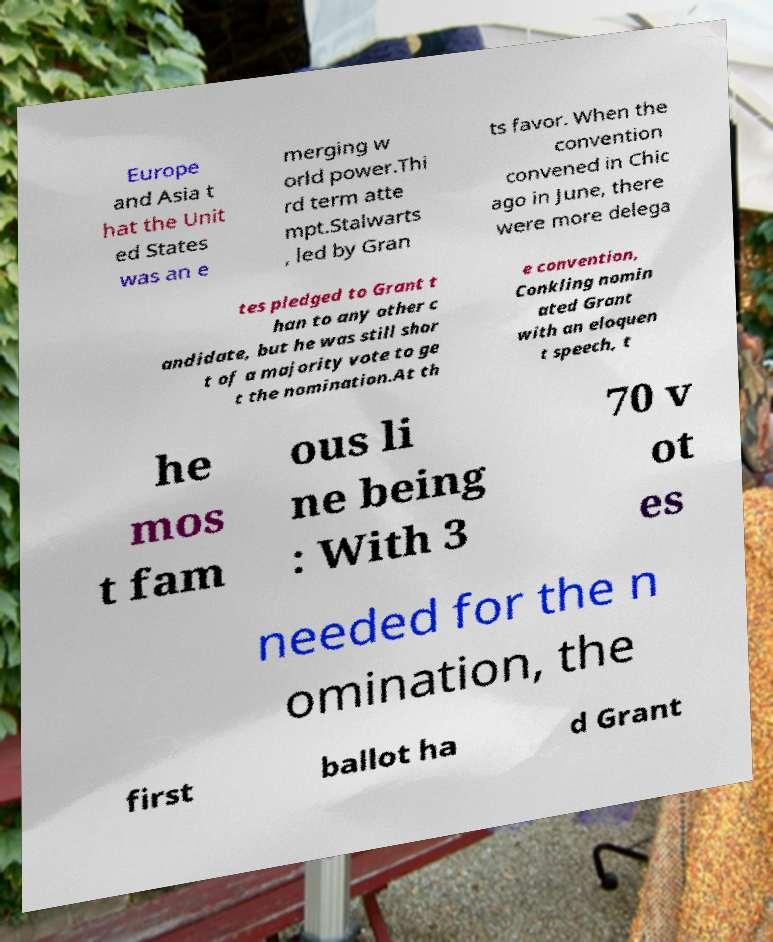Could you assist in decoding the text presented in this image and type it out clearly? Europe and Asia t hat the Unit ed States was an e merging w orld power.Thi rd term atte mpt.Stalwarts , led by Gran ts favor. When the convention convened in Chic ago in June, there were more delega tes pledged to Grant t han to any other c andidate, but he was still shor t of a majority vote to ge t the nomination.At th e convention, Conkling nomin ated Grant with an eloquen t speech, t he mos t fam ous li ne being : With 3 70 v ot es needed for the n omination, the first ballot ha d Grant 